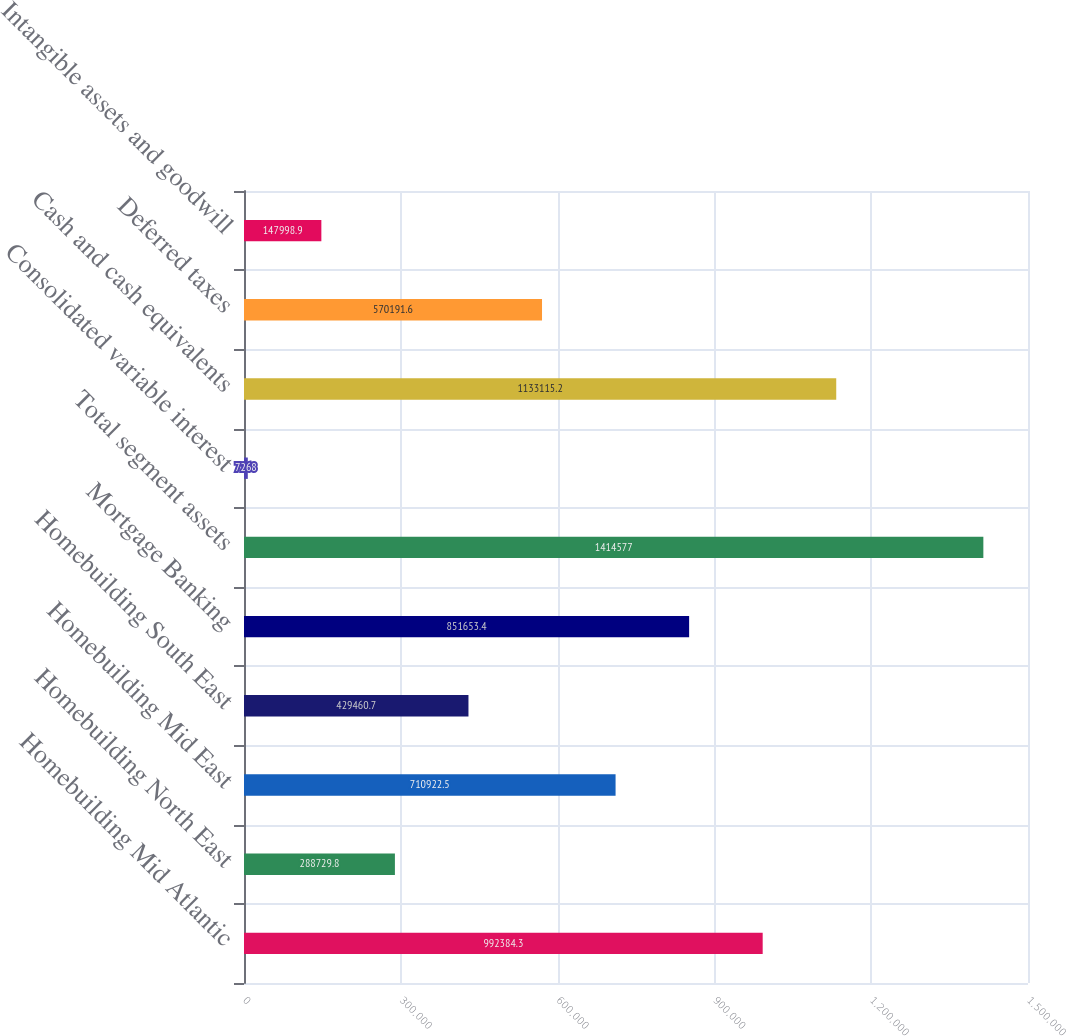Convert chart to OTSL. <chart><loc_0><loc_0><loc_500><loc_500><bar_chart><fcel>Homebuilding Mid Atlantic<fcel>Homebuilding North East<fcel>Homebuilding Mid East<fcel>Homebuilding South East<fcel>Mortgage Banking<fcel>Total segment assets<fcel>Consolidated variable interest<fcel>Cash and cash equivalents<fcel>Deferred taxes<fcel>Intangible assets and goodwill<nl><fcel>992384<fcel>288730<fcel>710922<fcel>429461<fcel>851653<fcel>1.41458e+06<fcel>7268<fcel>1.13312e+06<fcel>570192<fcel>147999<nl></chart> 